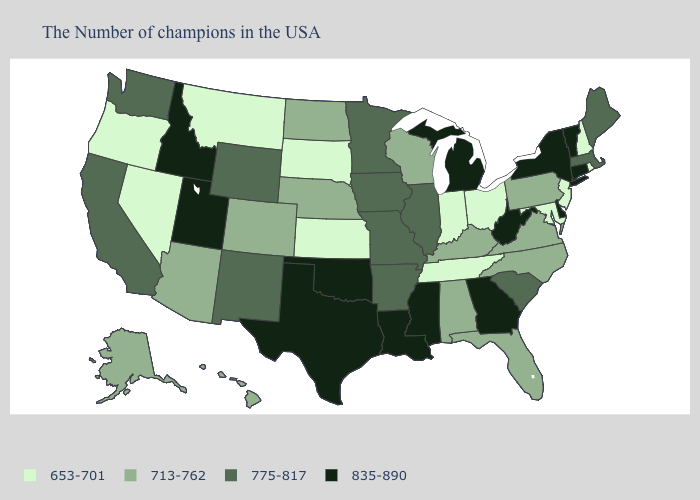Among the states that border Wisconsin , which have the lowest value?
Be succinct. Illinois, Minnesota, Iowa. What is the lowest value in the South?
Quick response, please. 653-701. Name the states that have a value in the range 835-890?
Be succinct. Vermont, Connecticut, New York, Delaware, West Virginia, Georgia, Michigan, Mississippi, Louisiana, Oklahoma, Texas, Utah, Idaho. Is the legend a continuous bar?
Quick response, please. No. What is the value of Massachusetts?
Give a very brief answer. 775-817. Does Georgia have the lowest value in the USA?
Short answer required. No. Which states have the lowest value in the Northeast?
Short answer required. Rhode Island, New Hampshire, New Jersey. What is the value of Vermont?
Quick response, please. 835-890. Name the states that have a value in the range 653-701?
Keep it brief. Rhode Island, New Hampshire, New Jersey, Maryland, Ohio, Indiana, Tennessee, Kansas, South Dakota, Montana, Nevada, Oregon. What is the value of Kentucky?
Be succinct. 713-762. Does the first symbol in the legend represent the smallest category?
Answer briefly. Yes. Does North Carolina have a higher value than South Dakota?
Concise answer only. Yes. Name the states that have a value in the range 713-762?
Short answer required. Pennsylvania, Virginia, North Carolina, Florida, Kentucky, Alabama, Wisconsin, Nebraska, North Dakota, Colorado, Arizona, Alaska, Hawaii. Among the states that border Wyoming , which have the lowest value?
Short answer required. South Dakota, Montana. Which states have the lowest value in the USA?
Be succinct. Rhode Island, New Hampshire, New Jersey, Maryland, Ohio, Indiana, Tennessee, Kansas, South Dakota, Montana, Nevada, Oregon. 